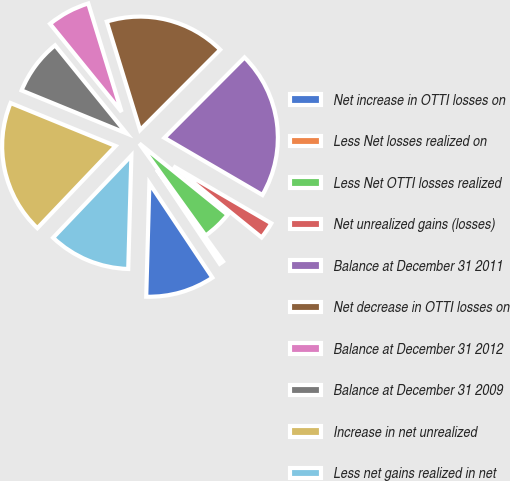Convert chart to OTSL. <chart><loc_0><loc_0><loc_500><loc_500><pie_chart><fcel>Net increase in OTTI losses on<fcel>Less Net losses realized on<fcel>Less Net OTTI losses realized<fcel>Net unrealized gains (losses)<fcel>Balance at December 31 2011<fcel>Net decrease in OTTI losses on<fcel>Balance at December 31 2012<fcel>Balance at December 31 2009<fcel>Increase in net unrealized<fcel>Less net gains realized in net<nl><fcel>9.81%<fcel>0.56%<fcel>4.26%<fcel>2.41%<fcel>20.93%<fcel>17.22%<fcel>6.11%<fcel>7.96%<fcel>19.07%<fcel>11.67%<nl></chart> 